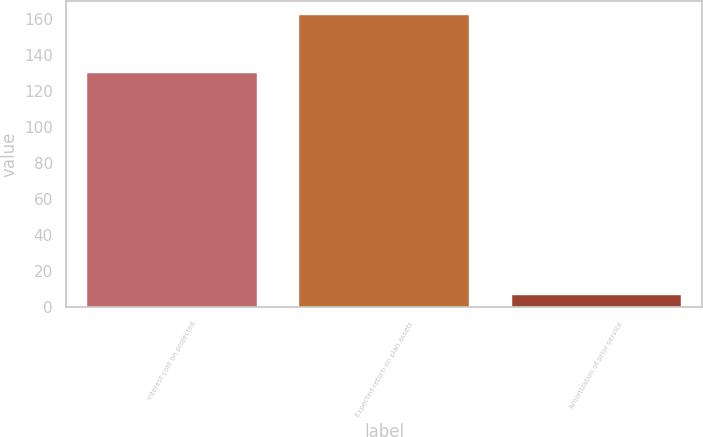<chart> <loc_0><loc_0><loc_500><loc_500><bar_chart><fcel>Interest cost on projected<fcel>Expected return on plan assets<fcel>Amortization of prior service<nl><fcel>130<fcel>162<fcel>7<nl></chart> 